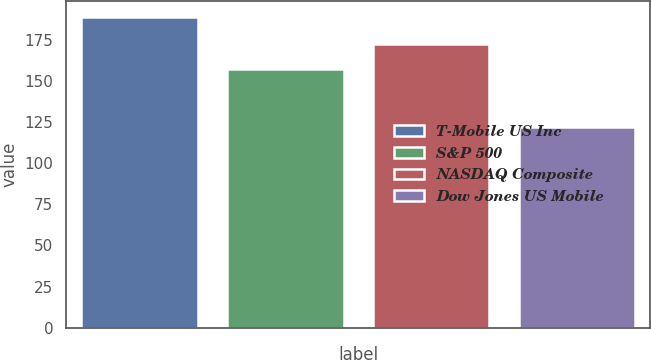Convert chart to OTSL. <chart><loc_0><loc_0><loc_500><loc_500><bar_chart><fcel>T-Mobile US Inc<fcel>S&P 500<fcel>NASDAQ Composite<fcel>Dow Jones US Mobile<nl><fcel>188.79<fcel>157.22<fcel>172.11<fcel>122.09<nl></chart> 